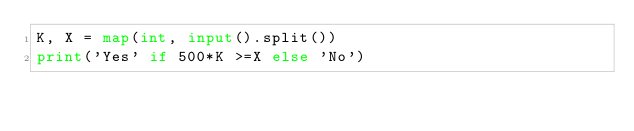Convert code to text. <code><loc_0><loc_0><loc_500><loc_500><_Python_>K, X = map(int, input().split())
print('Yes' if 500*K >=X else 'No')</code> 